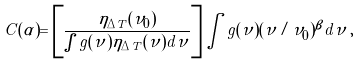Convert formula to latex. <formula><loc_0><loc_0><loc_500><loc_500>C ( \alpha ) = \left [ \frac { \eta _ { \Delta T } ( \nu _ { 0 } ) } { \int g ( \nu ) \eta _ { \Delta T } ( \nu ) d \nu } \right ] \int g ( \nu ) ( \nu / \nu _ { 0 } ) ^ { \beta } d \nu \, ,</formula> 